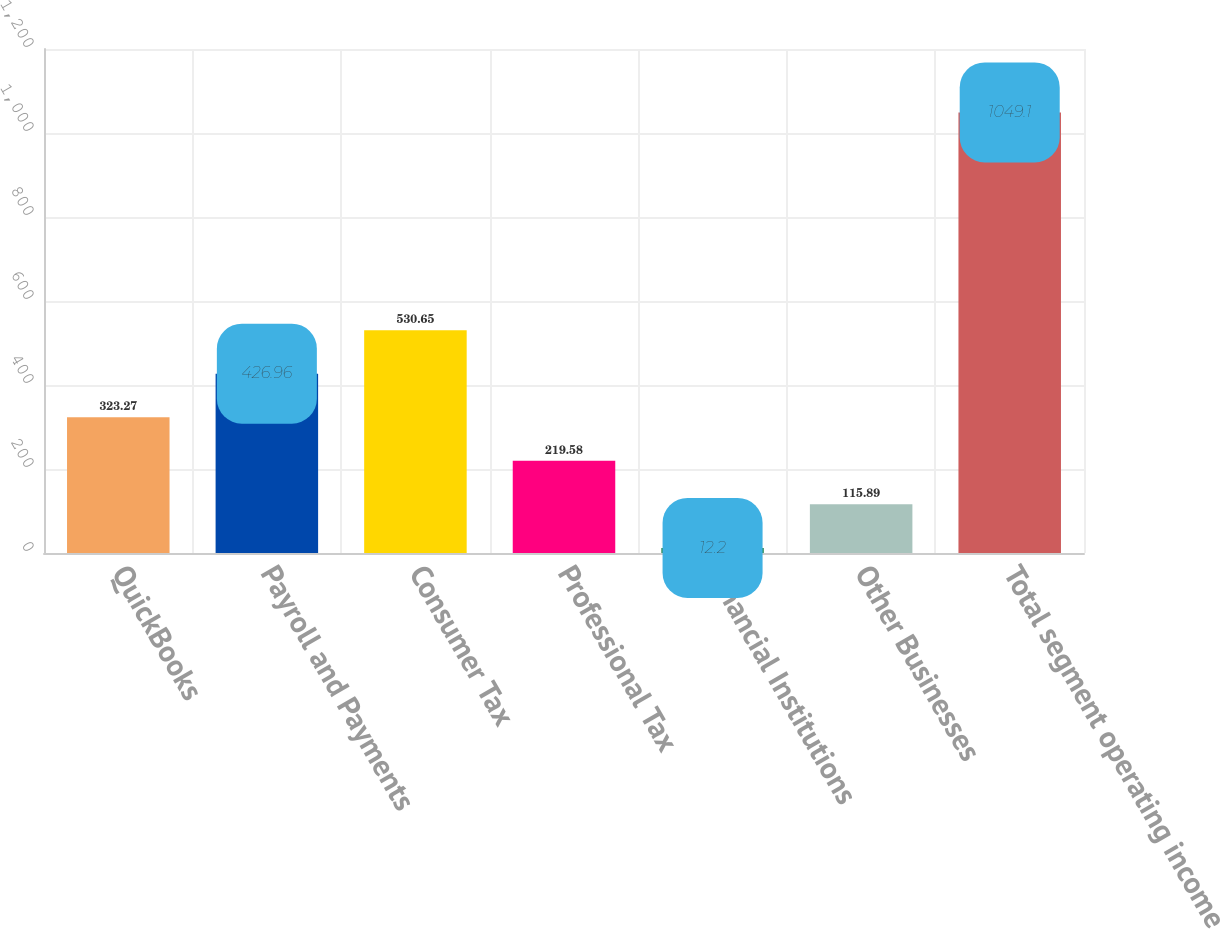<chart> <loc_0><loc_0><loc_500><loc_500><bar_chart><fcel>QuickBooks<fcel>Payroll and Payments<fcel>Consumer Tax<fcel>Professional Tax<fcel>Financial Institutions<fcel>Other Businesses<fcel>Total segment operating income<nl><fcel>323.27<fcel>426.96<fcel>530.65<fcel>219.58<fcel>12.2<fcel>115.89<fcel>1049.1<nl></chart> 